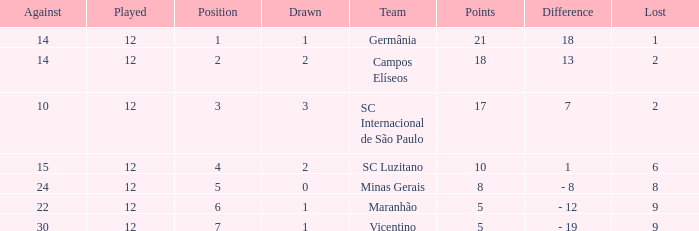What difference has a points greater than 10, and a drawn less than 2? 18.0. 